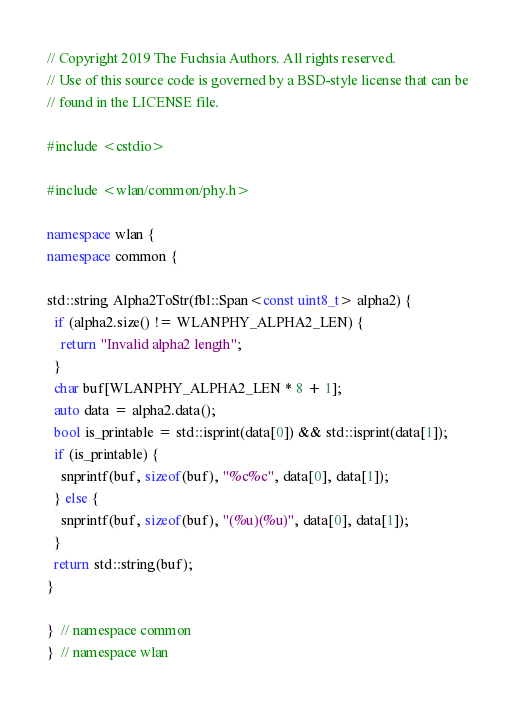<code> <loc_0><loc_0><loc_500><loc_500><_C++_>// Copyright 2019 The Fuchsia Authors. All rights reserved.
// Use of this source code is governed by a BSD-style license that can be
// found in the LICENSE file.

#include <cstdio>

#include <wlan/common/phy.h>

namespace wlan {
namespace common {

std::string Alpha2ToStr(fbl::Span<const uint8_t> alpha2) {
  if (alpha2.size() != WLANPHY_ALPHA2_LEN) {
    return "Invalid alpha2 length";
  }
  char buf[WLANPHY_ALPHA2_LEN * 8 + 1];
  auto data = alpha2.data();
  bool is_printable = std::isprint(data[0]) && std::isprint(data[1]);
  if (is_printable) {
    snprintf(buf, sizeof(buf), "%c%c", data[0], data[1]);
  } else {
    snprintf(buf, sizeof(buf), "(%u)(%u)", data[0], data[1]);
  }
  return std::string(buf);
}

}  // namespace common
}  // namespace wlan
</code> 